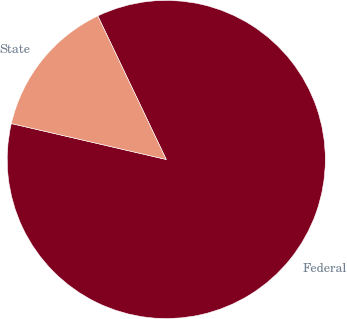<chart> <loc_0><loc_0><loc_500><loc_500><pie_chart><fcel>Federal<fcel>State<nl><fcel>85.71%<fcel>14.29%<nl></chart> 